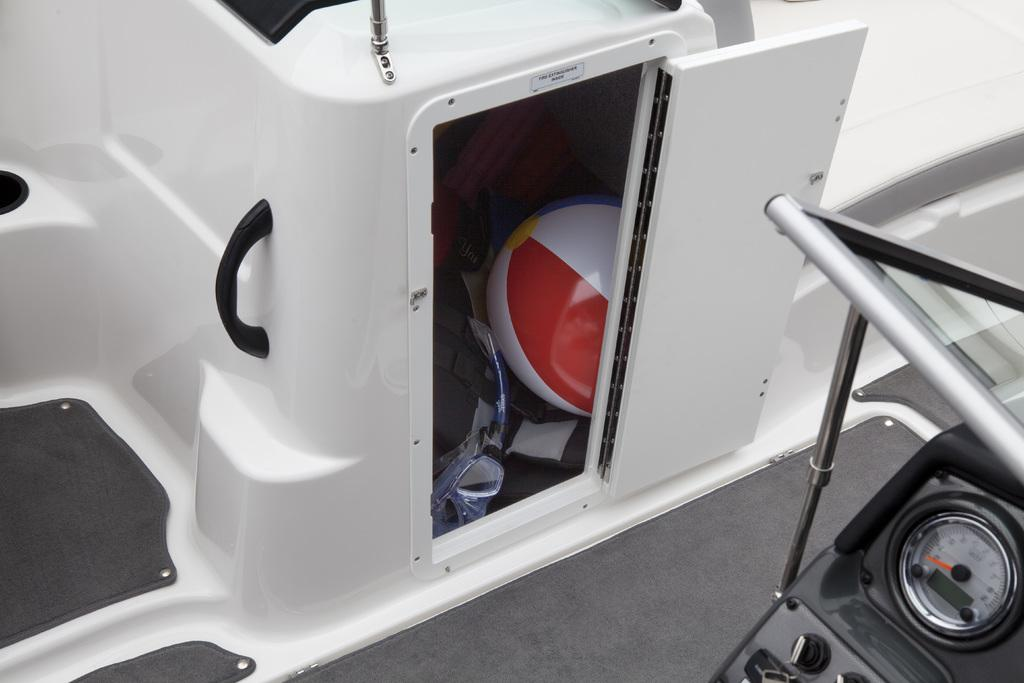What type of device is shown in the image? There is a speedometer in the image. What other objects can be seen in the image? There are regulators and a handle visible in the image. What is the main subject of the image? The image appears to depict a cupboard. What items are inside the cupboard? There is a ball and goggles present inside the cupboard. How does the wound on the airplane affect its flight in the image? There is no airplane or wound present in the image; it depicts a cupboard with a speedometer, regulators, a handle, and items inside. 